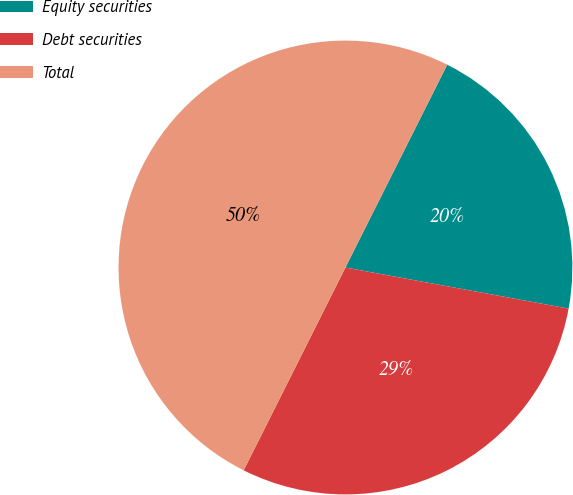Convert chart to OTSL. <chart><loc_0><loc_0><loc_500><loc_500><pie_chart><fcel>Equity securities<fcel>Debt securities<fcel>Total<nl><fcel>20.5%<fcel>29.5%<fcel>50.0%<nl></chart> 